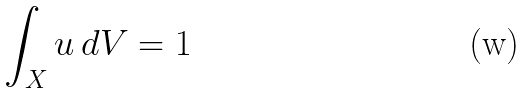Convert formula to latex. <formula><loc_0><loc_0><loc_500><loc_500>\int _ { X } u \, d V = 1</formula> 